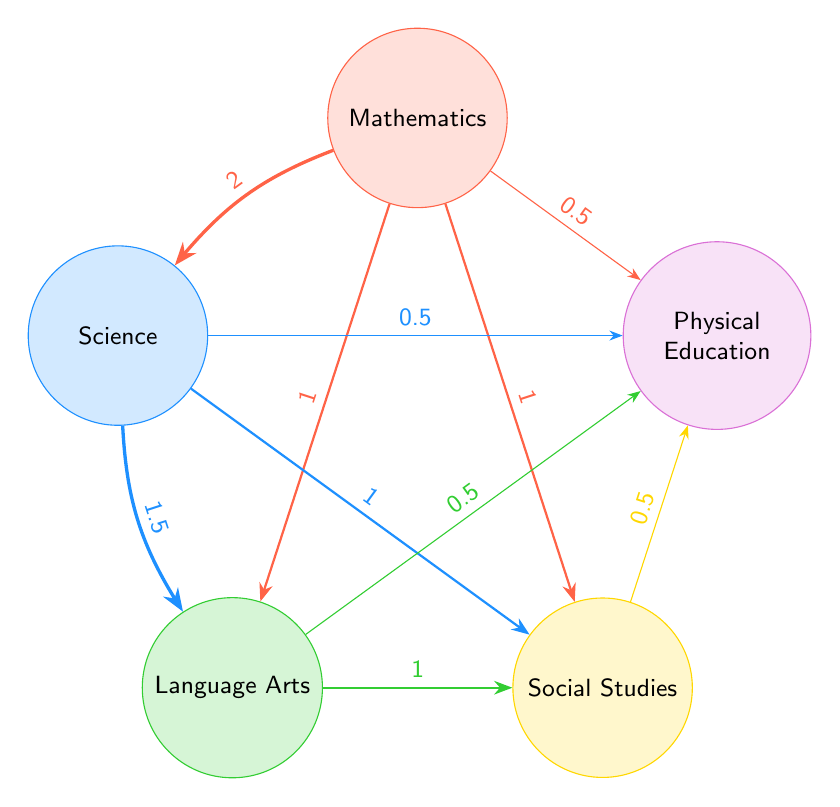What is the value of the connection between Mathematics and Science? The link between Mathematics and Science is directly represented in the diagram. By observing the arrow connecting these two nodes, we see a value of 2 labeled above the connection.
Answer: 2 How many subjects are represented in the diagram? The diagram displays five distinct subjects, which are visually indicated by the five nodes labeled as Mathematics, Science, Language Arts, Social Studies, and Physical Education.
Answer: 5 Which subject has the highest total connection value? To determine this, we add up the values of all outgoing connections for each subject. Mathematics has values of 2 + 1 + 1 + 0.5 = 4.5; Science has values of 1.5 + 1 + 0.5 = 3; Language Arts has values of 1 + 0.5 = 1.5; Social Studies has values of 1 + 0.5 = 1.5; Physical Education has no outgoing values. Thus, Mathematics has the highest total connection value of 4.5.
Answer: Mathematics What is the value of the connection between Language Arts and Social Studies? The value of the link from Language Arts to Social Studies can be found by examining the arrow between these two nodes. It shows a value of 1.
Answer: 1 How does the connection between Science and Language Arts compare to that between Mathematics and Social Studies? The connection value between Science and Language Arts is 1.5, while between Mathematics and Social Studies it is 1. Comparing these, 1.5 is greater than 1, indicating that Science has a stronger connection to Language Arts than Mathematics does to Social Studies.
Answer: Science to Language Arts is stronger What is the total connection value from Science to other subjects? Calculating the total connection values from the Science node, we add: 1.5 (to Language Arts) + 1 (to Social Studies) + 0.5 (to Physical Education) = 3. Thus, the total connection value is 3.
Answer: 3 Which subject connects to Physical Education through the fewest links? To find the subject connecting to Physical Education with the fewest links, we note that Mathematics has a connection of 0.5, Science also has a connection of 0.5, Language Arts has a connection of 0.5, and Social Studies has a connection of 0.5 as well. Each has one connection link to Physical Education.
Answer: All subjects (Mathematics, Science, Language Arts, and Social Studies) connect with one link 